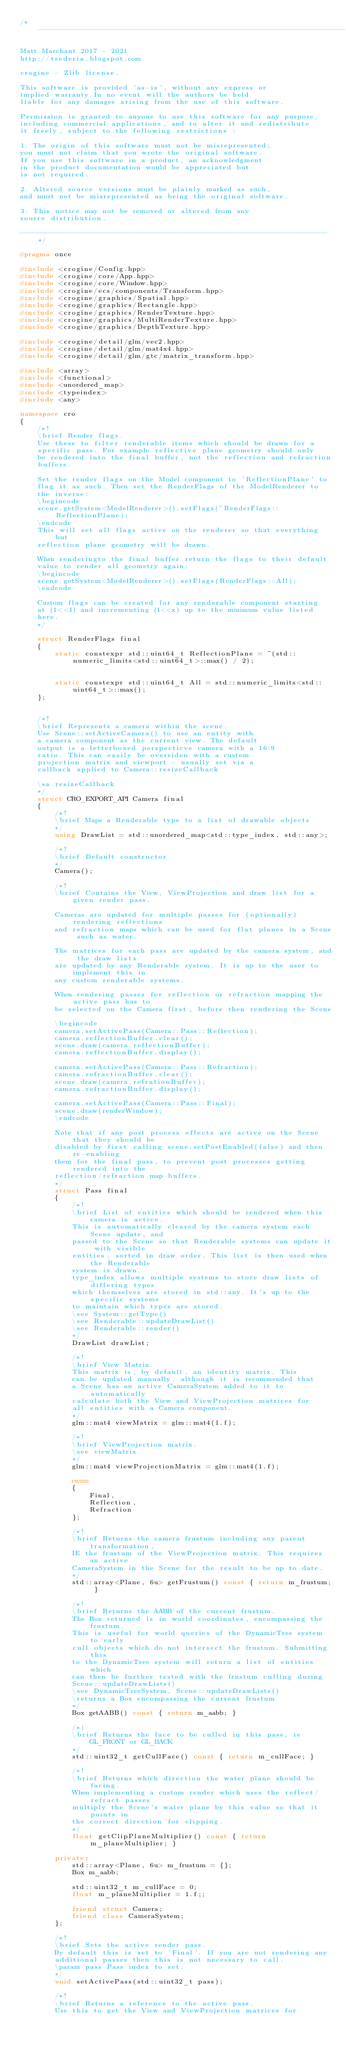<code> <loc_0><loc_0><loc_500><loc_500><_C++_>/*-----------------------------------------------------------------------

Matt Marchant 2017 - 2021
http://trederia.blogspot.com

crogine - Zlib license.

This software is provided 'as-is', without any express or
implied warranty.In no event will the authors be held
liable for any damages arising from the use of this software.

Permission is granted to anyone to use this software for any purpose,
including commercial applications, and to alter it and redistribute
it freely, subject to the following restrictions :

1. The origin of this software must not be misrepresented;
you must not claim that you wrote the original software.
If you use this software in a product, an acknowledgment
in the product documentation would be appreciated but
is not required.

2. Altered source versions must be plainly marked as such,
and must not be misrepresented as being the original software.

3. This notice may not be removed or altered from any
source distribution.

-----------------------------------------------------------------------*/

#pragma once

#include <crogine/Config.hpp>
#include <crogine/core/App.hpp>
#include <crogine/core/Window.hpp>
#include <crogine/ecs/components/Transform.hpp>
#include <crogine/graphics/Spatial.hpp>
#include <crogine/graphics/Rectangle.hpp>
#include <crogine/graphics/RenderTexture.hpp>
#include <crogine/graphics/MultiRenderTexture.hpp>
#include <crogine/graphics/DepthTexture.hpp>

#include <crogine/detail/glm/vec2.hpp>
#include <crogine/detail/glm/mat4x4.hpp>
#include <crogine/detail/glm/gtc/matrix_transform.hpp>

#include <array>
#include <functional>
#include <unordered_map>
#include <typeindex>
#include <any>

namespace cro
{
    /*!
    \brief Render flags.
    Use these to filter renderable items which should be drawn for a
    specific pass. For example reflective plane geometry should only
    be rendered into the final buffer, not the reflection and refraction
    buffers.

    Set the render flags on the Model component to 'ReflectionPlane' to
    flag it as such. Then set the RenderFlags of the ModelRenderer to
    the inverse:
    \begincode
    scene.getSystem<ModelRenderer>().setFlags(~RenderFlags::ReflectionPlane);
    \endcode
    This will set all flags active on the renderer so that everything but
    reflection plane geometry will be drawn.

    When renderingto the final buffer return the flags to their default
    value to render all geometry again:
    \begincode
    scene.getSystem<ModelRenderer>().setFlags(RenderFlags::All);
    \endcode

    Custom flags can be created for any renderable component starting
    at (1<<1) and incrementing (1<<x) up to the minimum value listed
    here.
    */

    struct RenderFlags final
    {
        static constexpr std::uint64_t ReflectionPlane = ~(std::numeric_limits<std::uint64_t>::max() / 2);


        static constexpr std::uint64_t All = std::numeric_limits<std::uint64_t>::max();
    };


    /*!
    \brief Represents a camera within the scene.
    Use Scene::setActiveCamera() to use an entity with
    a camera component as the current view. The default
    output is a letterboxed perspecticve camera with a 16:9
    ratio. This can easily be overriden with a custom
    projection matrix and viewport - usually set via a
    callback applied to Camera::resizeCallback

    \sa resizeCallback
    */
    struct CRO_EXPORT_API Camera final
    {
        /*!
        \brief Maps a Renderable type to a list of drawable objects
        */
        using DrawList = std::unordered_map<std::type_index, std::any>;

        /*!
        \brief Default constructor
        */
        Camera();

        /*!
        \brief Contains the View, ViewProjection and draw list for a given render pass.

        Cameras are updated for multiple passes for (optionally) rendering reflections
        and refraction maps which can be used for flat planes in a Scene such as water.

        The matrices for each pass are updated by the camera system, and the draw lists
        are updated by any Renderable system. It is up to the user to implement this in
        any custom renderable systems.

        When rendering passes for reflection or refraction mapping the active pass has to
        be selected on the Camera first, before then rendering the Scene

        \begincode
        camera.setActivePass(Camera::Pass::Reflection);
        camera.reflectionBuffer.clear();
        scene.draw(camera.reflectionBuffer);
        camera.reflectionBuffer.display();

        camera.setActivePass(Camera::Pass::Refraction);
        camera.refractionBuffer.clear();
        scene.draw(camera.refrationBuffer);
        camera.refractionBuffer.display();

        camera.setActivePass(Camera::Pass::Final);
        scene.draw(renderWindow);
        \endcode

        Note that if any post process effects are active on the Scene that they should be
        disabled by first calling scene.setPostEnabled(false) and then re-enabling
        them for the final pass, to prevent post processes getting rendered into the
        reflection/refraction map buffers.
        */
        struct Pass final
        {
            /*!
            \brief List of entities which should be rendered when this camera is active.
            This is automatically cleared by the camera system each Scene update, and
            passed to the Scene so that Renderable systems can update it with visible
            entities, sorted in draw order. This list is then used when the Renderable
            system is drawn.
            type_index allows multiple systems to store draw lists of differing types
            which themselves are stored in std::any. It's up to the specific systems
            to maintain which types are stored.
            \see System::getType()
            \see Renderable::updateDrawList()
            \see Renderable::render()
            */
            DrawList drawList;

            /*!
            \brief View Matrix.
            This matrix is, by default, an identity matrix. This
            can be updated manually, although it is recommended that
            a Scene has an active CameraSystem added to it to automatically
            calculate both the View and ViewProjection matrices for
            all entities with a Camera component.
            */
            glm::mat4 viewMatrix = glm::mat4(1.f);

            /*!
            \brief ViewProjection matrix.
            \see viewMatrix
            */
            glm::mat4 viewProjectionMatrix = glm::mat4(1.f);

            enum
            {
                Final,
                Reflection,
                Refraction
            };

            /*!
            \brief Returns the camera frustum including any parent transformation,
            IE the frustum of the ViewProjection matrix. This requires an active
            CameraSystem in the Scene for the result to be up to date.
            */
            std::array<Plane, 6u> getFrustum() const { return m_frustum; }

            /*!
            \brief Returns the AABB of the current frustum.
            The Box returned is in world coordinates, encompassing the frustum.
            This is useful for world queries of the DynamicTree system to early
            cull objects which do not intersect the frustum. Submitting this
            to the DynamicTree system will return a list of entities which
            can then be further tested with the frustum culling during
            Scene::updateDrawLists()
            \see DynamicTreeSystem, Scene::updateDrawLists()
            \returns a Box encompassing the current frustum
            */
            Box getAABB() const { return m_aabb; }

            /*|
            \brief Returns the face to be culled in this pass, ie GL_FRONT or GL_BACK
            */
            std::uint32_t getCullFace() const { return m_cullFace; }

            /*!
            \brief Returns which direction the water plane should be facing.
            When implementing a custom render which uses the reflect/refract passes
            multiply the Scene's water plane by this value so that it points in
            the correct direction for clipping.
            */
            float getClipPlaneMultiplier() const { return m_planeMultiplier; }

        private:
            std::array<Plane, 6u> m_frustum = {};
            Box m_aabb;

            std::uint32_t m_cullFace = 0;
            float m_planeMultiplier = 1.f;;

            friend struct Camera;
            friend class CameraSystem;
        };

        /*!
        \brief Sets the active render pass.
        By default this is set to 'Final'. If you are not rendering any
        additional passes then this is not necessary to call.
        \param pass Pass index to set.
        */
        void setActivePass(std::uint32_t pass);

        /*!
        \brief Returns a reference to the active pass.
        Use this to get the View and ViewProjection matrices for</code> 